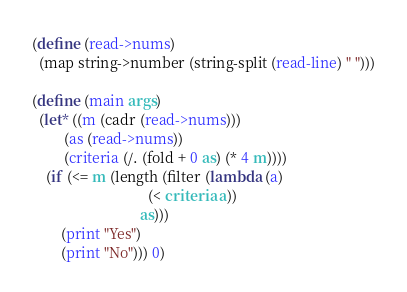Convert code to text. <code><loc_0><loc_0><loc_500><loc_500><_Scheme_>(define (read->nums)
  (map string->number (string-split (read-line) " ")))

(define (main args)
  (let* ((m (cadr (read->nums)))
         (as (read->nums))
         (criteria (/. (fold + 0 as) (* 4 m))))
    (if (<= m (length (filter (lambda (a)
                                (< criteria a))
                              as)))
        (print "Yes")
        (print "No"))) 0)
</code> 